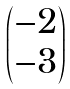Convert formula to latex. <formula><loc_0><loc_0><loc_500><loc_500>\begin{pmatrix} - 2 \\ - 3 \end{pmatrix}</formula> 